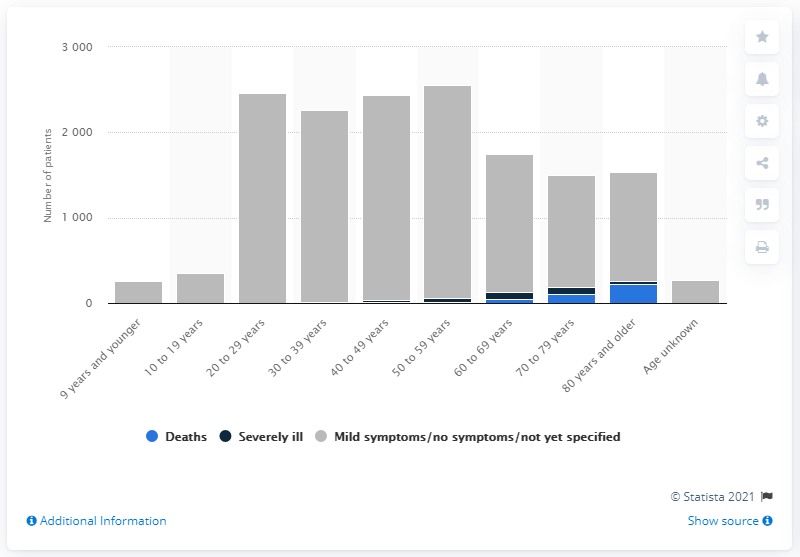Give some essential details in this illustration. It is estimated that 228 people have died as a result of COVID-19. As of May 7, 2020, there were 89 confirmed cases of COVID-19 in Japan. 